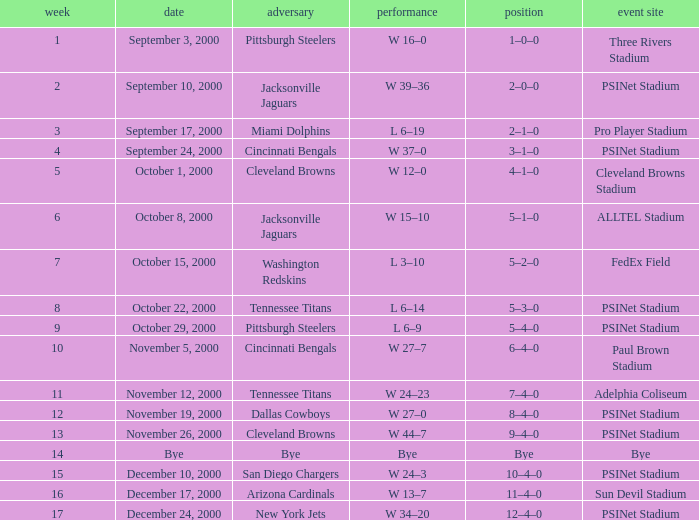What's the result at psinet stadium when the cincinnati bengals are the opponent? W 37–0. Can you parse all the data within this table? {'header': ['week', 'date', 'adversary', 'performance', 'position', 'event site'], 'rows': [['1', 'September 3, 2000', 'Pittsburgh Steelers', 'W 16–0', '1–0–0', 'Three Rivers Stadium'], ['2', 'September 10, 2000', 'Jacksonville Jaguars', 'W 39–36', '2–0–0', 'PSINet Stadium'], ['3', 'September 17, 2000', 'Miami Dolphins', 'L 6–19', '2–1–0', 'Pro Player Stadium'], ['4', 'September 24, 2000', 'Cincinnati Bengals', 'W 37–0', '3–1–0', 'PSINet Stadium'], ['5', 'October 1, 2000', 'Cleveland Browns', 'W 12–0', '4–1–0', 'Cleveland Browns Stadium'], ['6', 'October 8, 2000', 'Jacksonville Jaguars', 'W 15–10', '5–1–0', 'ALLTEL Stadium'], ['7', 'October 15, 2000', 'Washington Redskins', 'L 3–10', '5–2–0', 'FedEx Field'], ['8', 'October 22, 2000', 'Tennessee Titans', 'L 6–14', '5–3–0', 'PSINet Stadium'], ['9', 'October 29, 2000', 'Pittsburgh Steelers', 'L 6–9', '5–4–0', 'PSINet Stadium'], ['10', 'November 5, 2000', 'Cincinnati Bengals', 'W 27–7', '6–4–0', 'Paul Brown Stadium'], ['11', 'November 12, 2000', 'Tennessee Titans', 'W 24–23', '7–4–0', 'Adelphia Coliseum'], ['12', 'November 19, 2000', 'Dallas Cowboys', 'W 27–0', '8–4–0', 'PSINet Stadium'], ['13', 'November 26, 2000', 'Cleveland Browns', 'W 44–7', '9–4–0', 'PSINet Stadium'], ['14', 'Bye', 'Bye', 'Bye', 'Bye', 'Bye'], ['15', 'December 10, 2000', 'San Diego Chargers', 'W 24–3', '10–4–0', 'PSINet Stadium'], ['16', 'December 17, 2000', 'Arizona Cardinals', 'W 13–7', '11–4–0', 'Sun Devil Stadium'], ['17', 'December 24, 2000', 'New York Jets', 'W 34–20', '12–4–0', 'PSINet Stadium']]} 